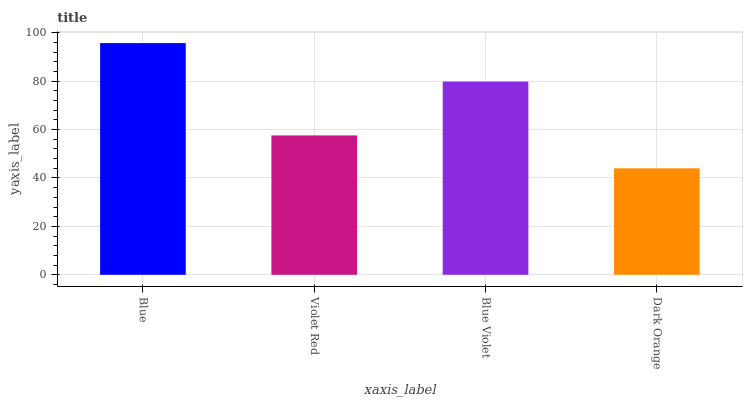Is Dark Orange the minimum?
Answer yes or no. Yes. Is Blue the maximum?
Answer yes or no. Yes. Is Violet Red the minimum?
Answer yes or no. No. Is Violet Red the maximum?
Answer yes or no. No. Is Blue greater than Violet Red?
Answer yes or no. Yes. Is Violet Red less than Blue?
Answer yes or no. Yes. Is Violet Red greater than Blue?
Answer yes or no. No. Is Blue less than Violet Red?
Answer yes or no. No. Is Blue Violet the high median?
Answer yes or no. Yes. Is Violet Red the low median?
Answer yes or no. Yes. Is Blue the high median?
Answer yes or no. No. Is Blue Violet the low median?
Answer yes or no. No. 